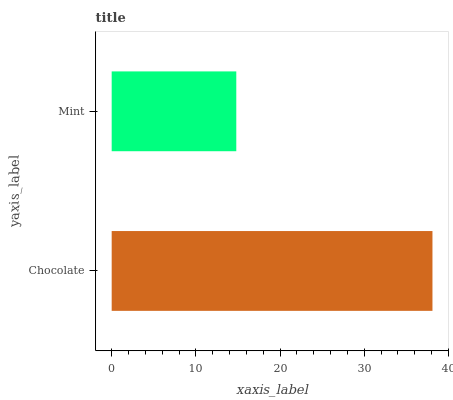Is Mint the minimum?
Answer yes or no. Yes. Is Chocolate the maximum?
Answer yes or no. Yes. Is Mint the maximum?
Answer yes or no. No. Is Chocolate greater than Mint?
Answer yes or no. Yes. Is Mint less than Chocolate?
Answer yes or no. Yes. Is Mint greater than Chocolate?
Answer yes or no. No. Is Chocolate less than Mint?
Answer yes or no. No. Is Chocolate the high median?
Answer yes or no. Yes. Is Mint the low median?
Answer yes or no. Yes. Is Mint the high median?
Answer yes or no. No. Is Chocolate the low median?
Answer yes or no. No. 